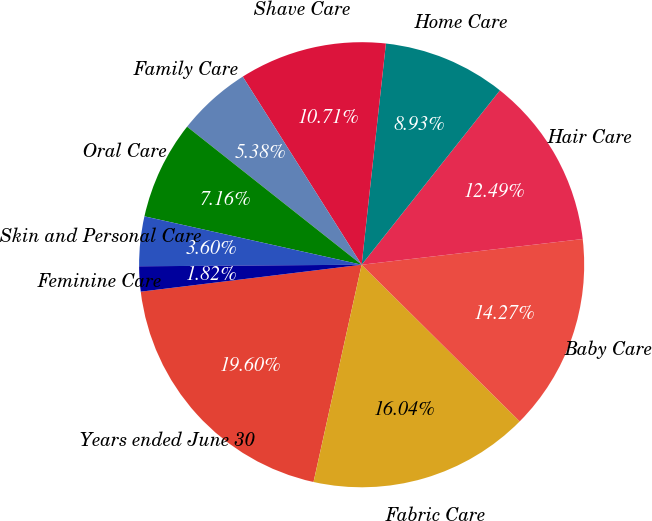Convert chart. <chart><loc_0><loc_0><loc_500><loc_500><pie_chart><fcel>Years ended June 30<fcel>Fabric Care<fcel>Baby Care<fcel>Hair Care<fcel>Home Care<fcel>Shave Care<fcel>Family Care<fcel>Oral Care<fcel>Skin and Personal Care<fcel>Feminine Care<nl><fcel>19.6%<fcel>16.04%<fcel>14.27%<fcel>12.49%<fcel>8.93%<fcel>10.71%<fcel>5.38%<fcel>7.16%<fcel>3.6%<fcel>1.82%<nl></chart> 